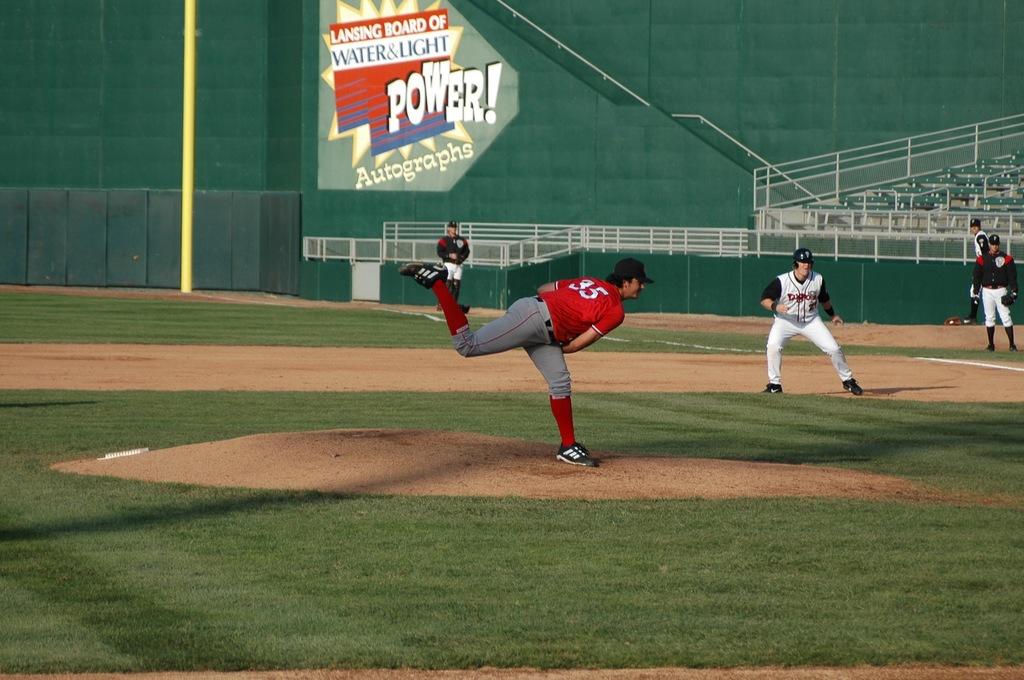What word is big and white on the board behind the player?
Offer a terse response. Power. What number is the pitcher?
Your answer should be compact. 35. 